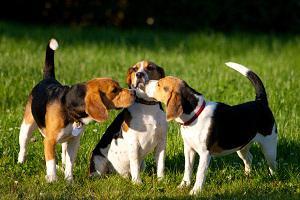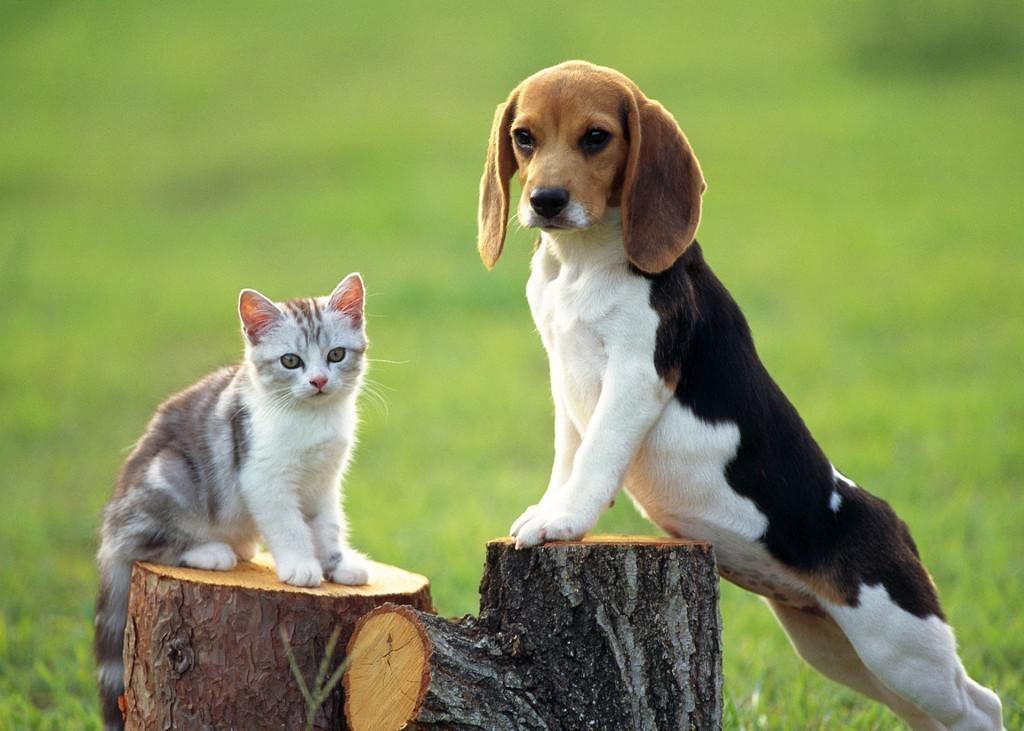The first image is the image on the left, the second image is the image on the right. Assess this claim about the two images: "The left image contains at least three dogs.". Correct or not? Answer yes or no. Yes. 